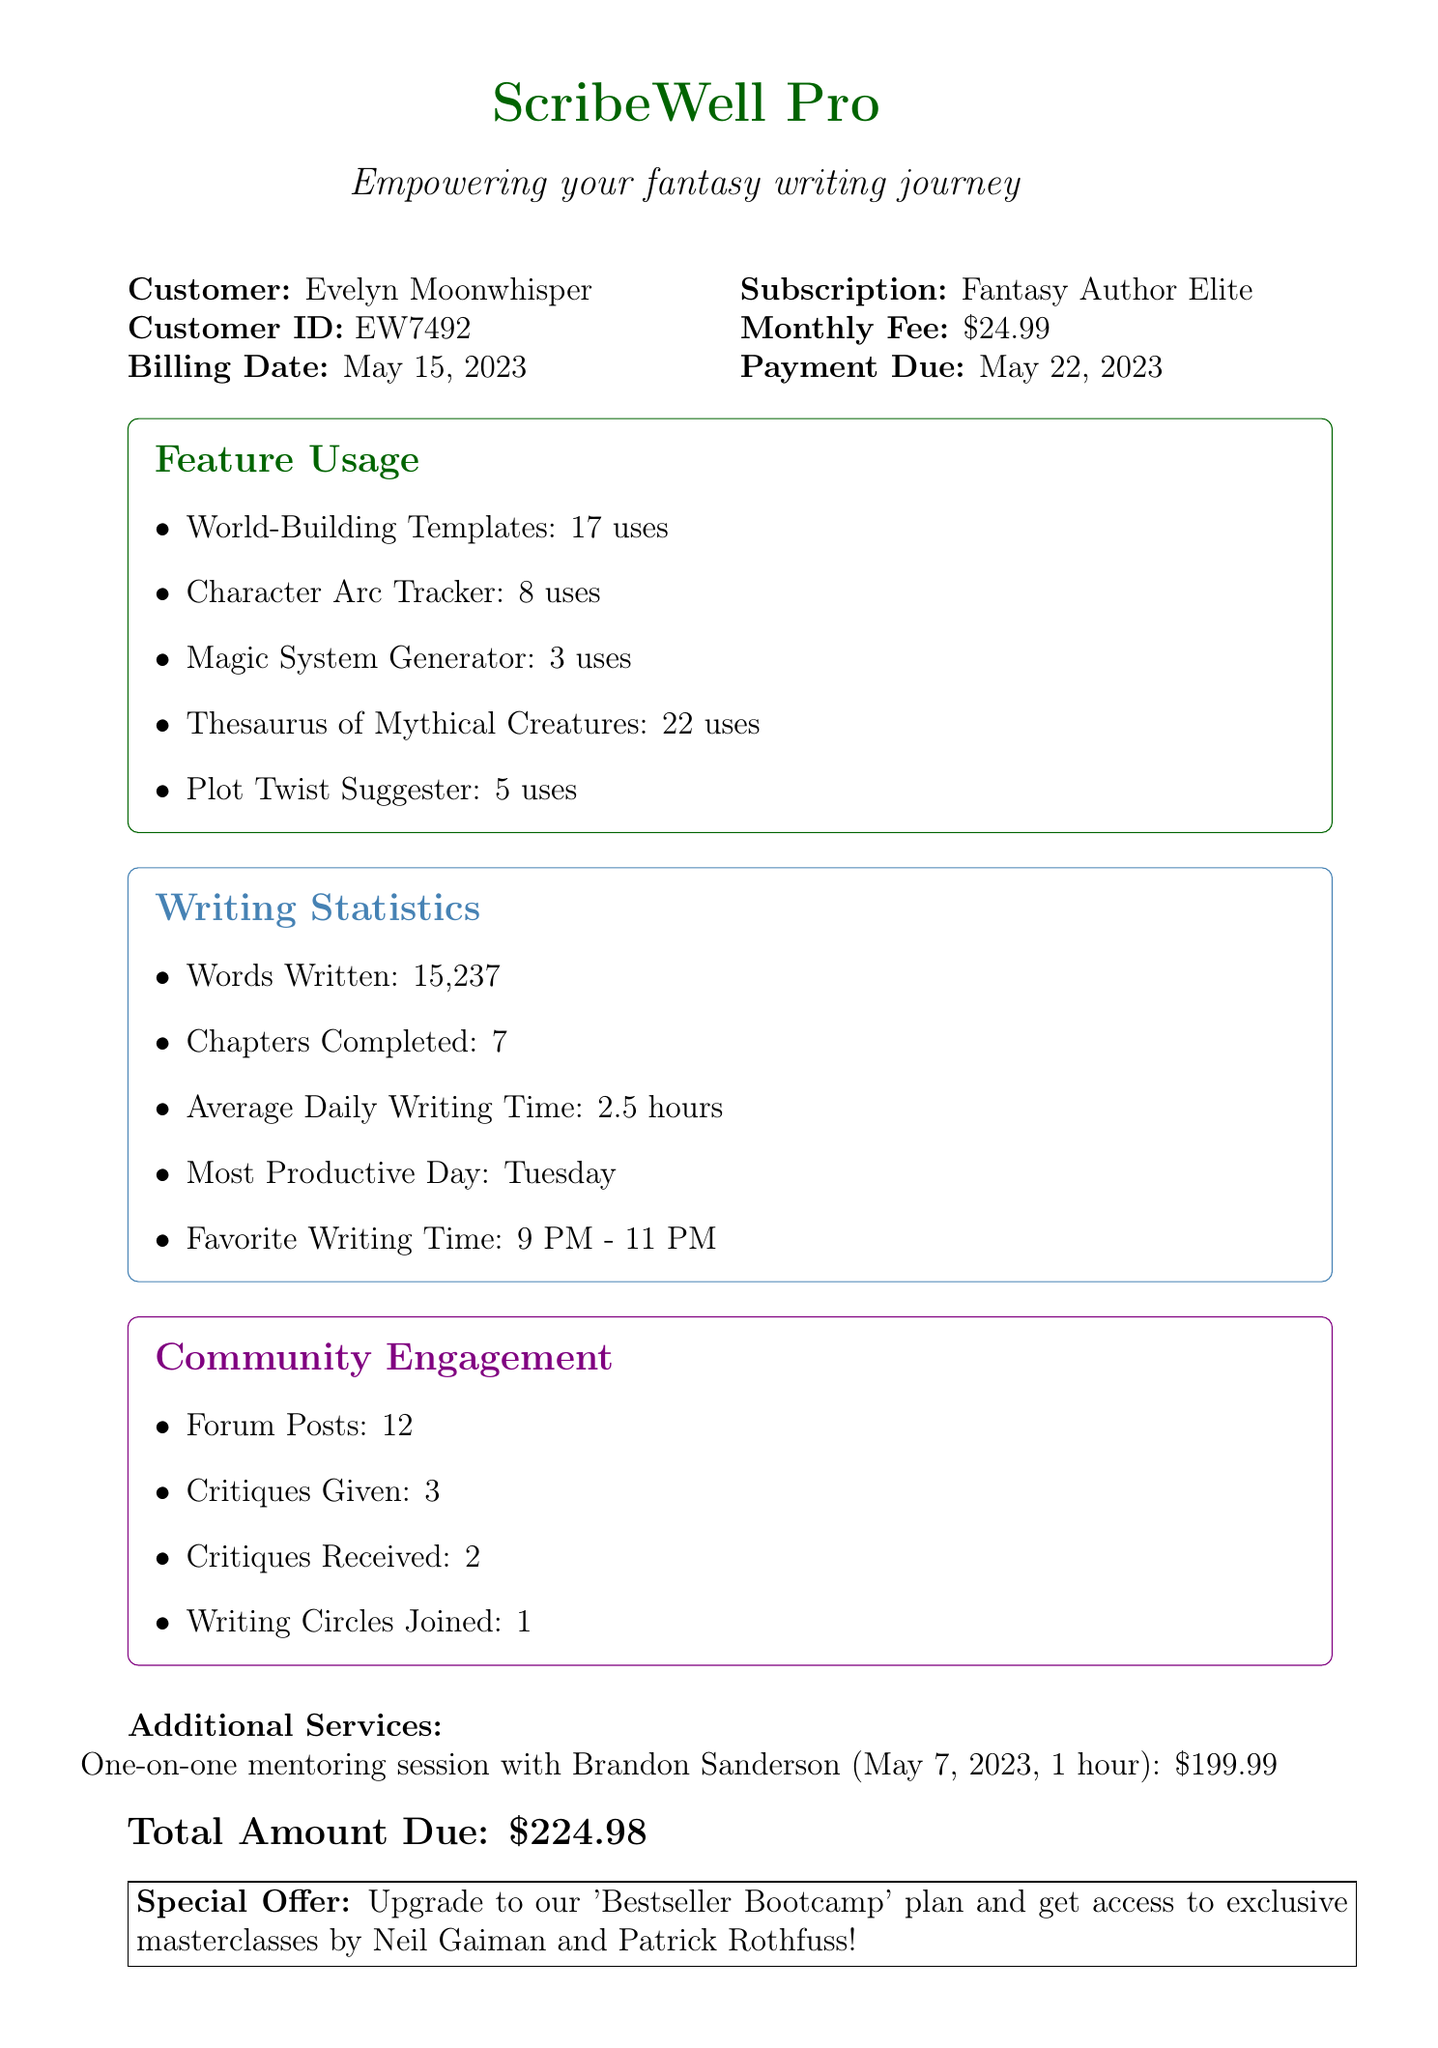What is the name of the company? The company's name is stated at the beginning of the document.
Answer: ScribeWell Pro What is the customer's name? The customer's name is provided in the document details.
Answer: Evelyn Moonwhisper What is the monthly fee for the subscription? The monthly fee is listed under the subscription details in the document.
Answer: $24.99 How many words has the customer written? The total word count written by the customer is provided in the writing statistics section.
Answer: 15,237 How many community engagements has the customer participated in? The total community engagement activities are summed up in the community engagement section.
Answer: 18 What is the total amount due? The total amount due is clearly indicated in the billing section of the document.
Answer: $224.98 When is the payment due date? The payment due date is specified in the billing information.
Answer: May 22, 2023 How many uses did the customer log for the Thesaurus of Mythical Creatures? The usage for each feature is detailed in the feature usage section of the document.
Answer: 22 What type of mentoring session did the customer have? The document specifies the type of additional service provided.
Answer: One-on-one mentoring session with Brandon Sanderson 